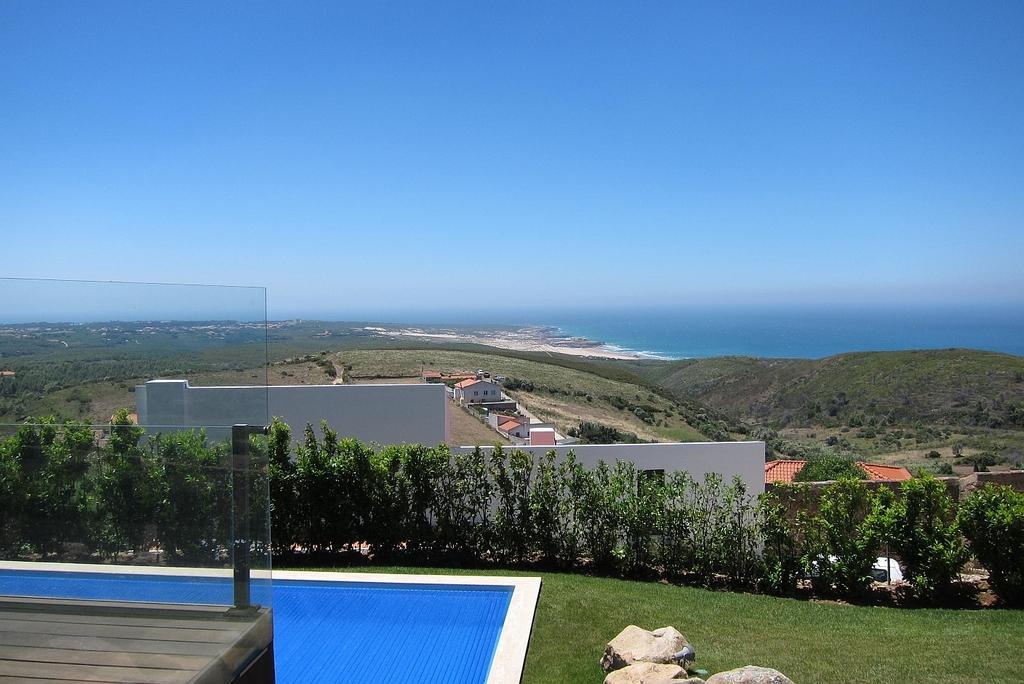Can you describe this image briefly? In this picture we can see rocks, swimming pool, grass, plants, houses and glass. In the background of the image we can see water and sky. 